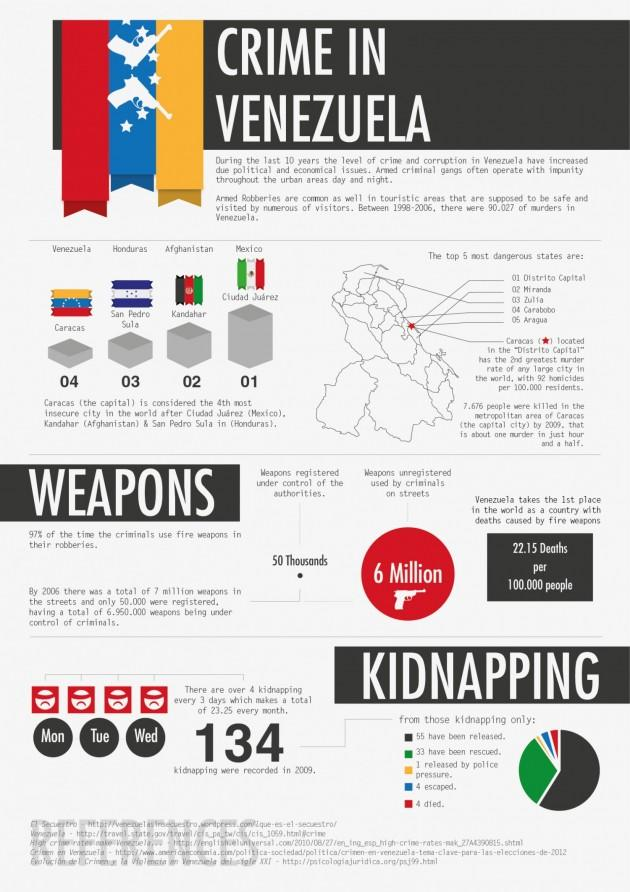Give some essential details in this illustration. In 2009, a total of 134 cases of kidnapping were reported in Venezuela. Kandahar is considered the second most dangerous city in the world. According to estimates, over 50,000 weapons are currently registered under the control of authorities in Venezuela. In 2009, 134 people were kidnapped in Venezuela, and 4 people died as a result of these kidnappings. According to estimates, there are approximately 6 million unregistered weapons being used by criminals on the streets of Venezuela. 